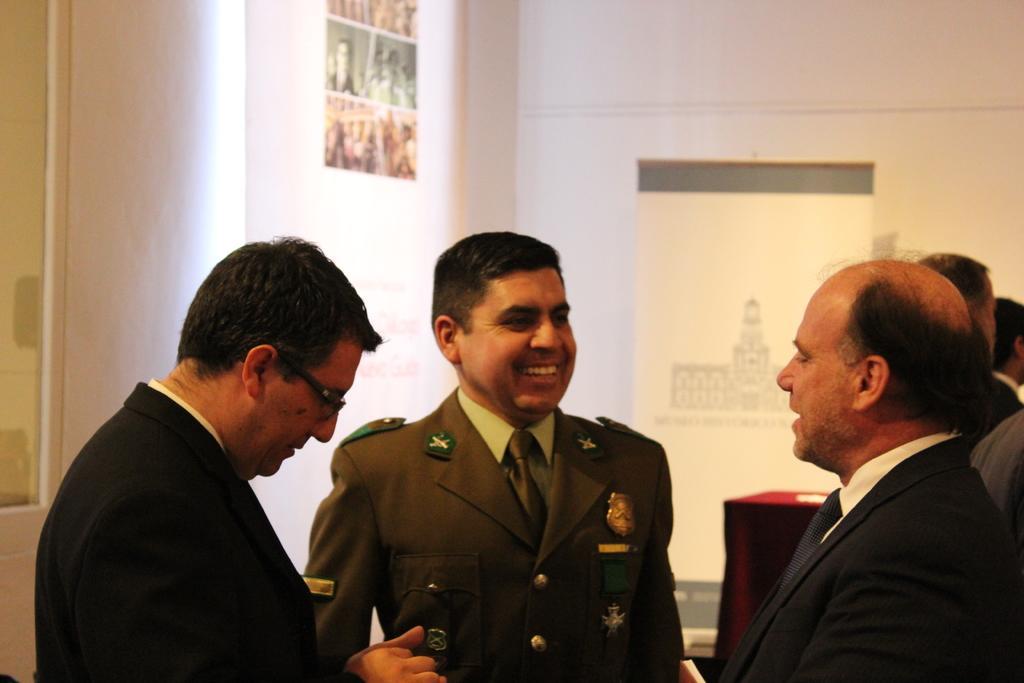Can you describe this image briefly? In this image we can see a group of people standing. One person is wearing a military uniform. One person is wearing a black coat and spectacles he background, we can see a table, banner and photo frames on the wall. 